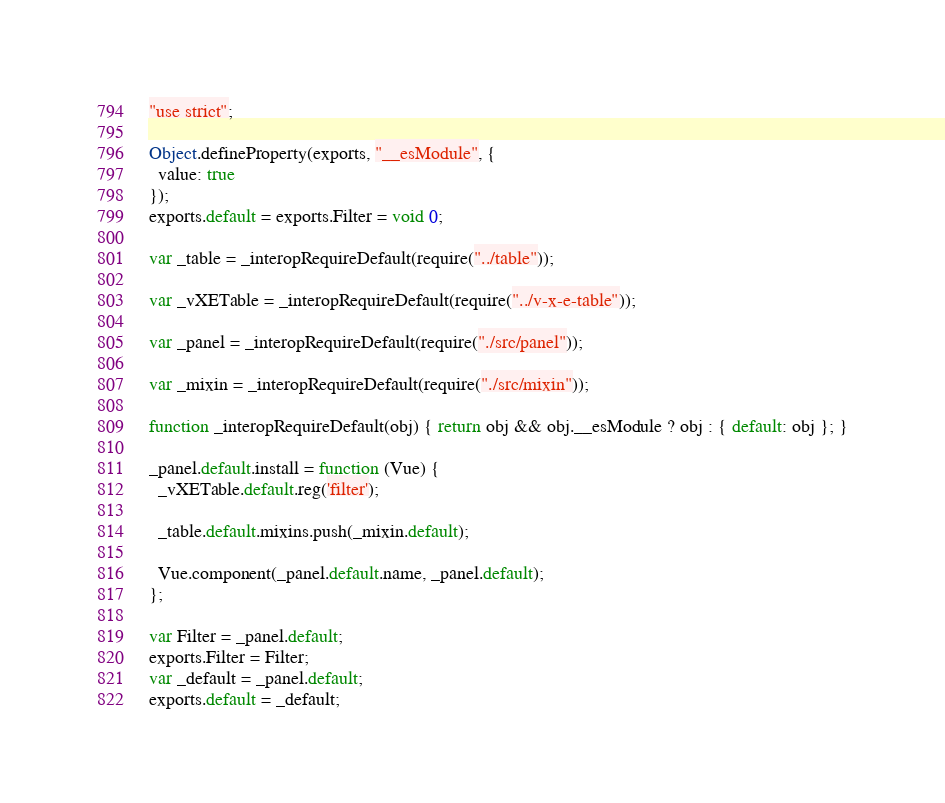<code> <loc_0><loc_0><loc_500><loc_500><_JavaScript_>"use strict";

Object.defineProperty(exports, "__esModule", {
  value: true
});
exports.default = exports.Filter = void 0;

var _table = _interopRequireDefault(require("../table"));

var _vXETable = _interopRequireDefault(require("../v-x-e-table"));

var _panel = _interopRequireDefault(require("./src/panel"));

var _mixin = _interopRequireDefault(require("./src/mixin"));

function _interopRequireDefault(obj) { return obj && obj.__esModule ? obj : { default: obj }; }

_panel.default.install = function (Vue) {
  _vXETable.default.reg('filter');

  _table.default.mixins.push(_mixin.default);

  Vue.component(_panel.default.name, _panel.default);
};

var Filter = _panel.default;
exports.Filter = Filter;
var _default = _panel.default;
exports.default = _default;</code> 